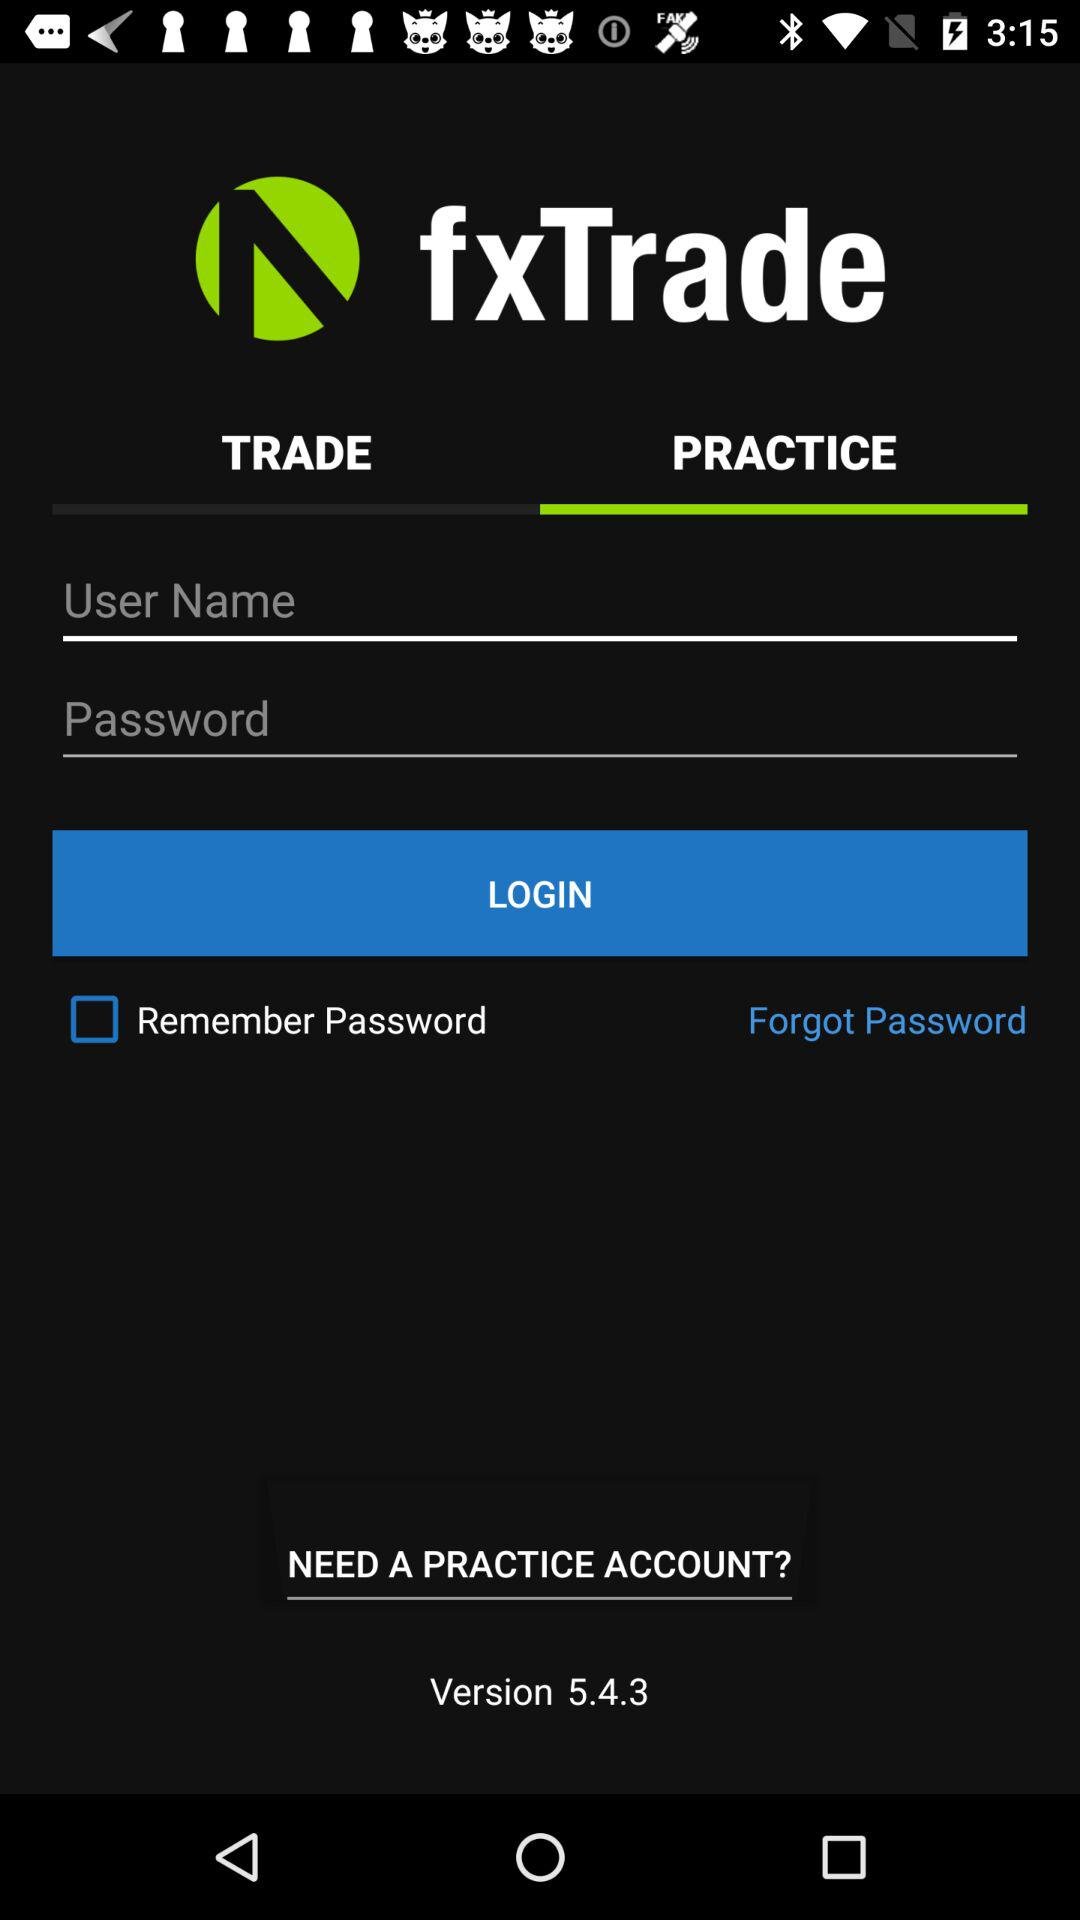How many text fields are there in the login form?
Answer the question using a single word or phrase. 2 